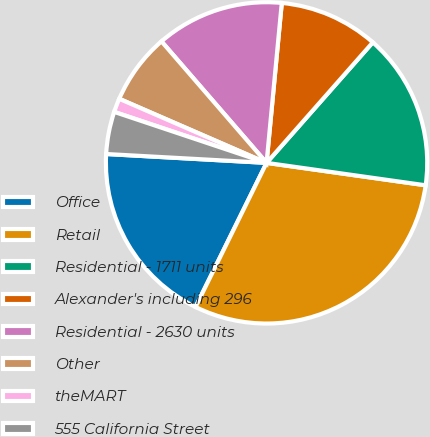<chart> <loc_0><loc_0><loc_500><loc_500><pie_chart><fcel>Office<fcel>Retail<fcel>Residential - 1711 units<fcel>Alexander's including 296<fcel>Residential - 2630 units<fcel>Other<fcel>theMART<fcel>555 California Street<nl><fcel>18.59%<fcel>30.06%<fcel>15.73%<fcel>9.99%<fcel>12.86%<fcel>7.12%<fcel>1.39%<fcel>4.26%<nl></chart> 